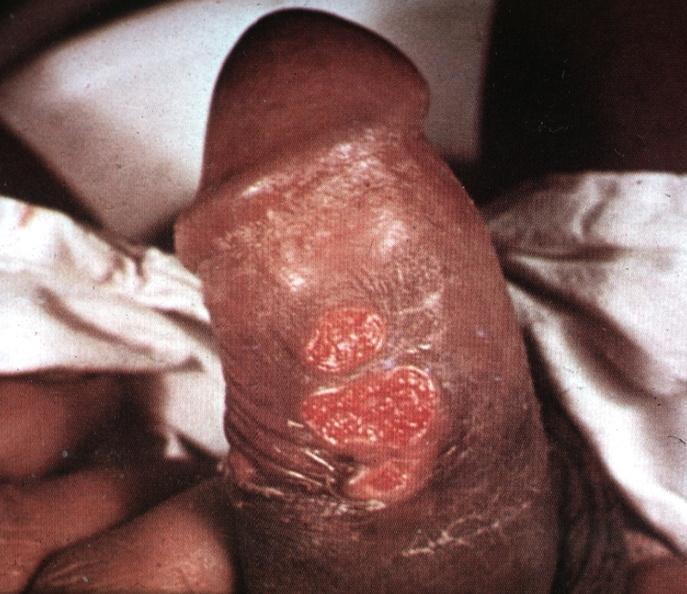what is labeled chancroid?
Answer the question using a single word or phrase. Ulcerative lesions slide 